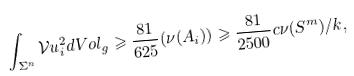<formula> <loc_0><loc_0><loc_500><loc_500>\int _ { \Sigma ^ { n } } \mathcal { V } u _ { i } ^ { 2 } d V o l _ { g } \geqslant \frac { 8 1 } { 6 2 5 } ( \nu ( A _ { i } ) ) \geqslant \frac { 8 1 } { 2 5 0 0 } c \nu ( S ^ { m } ) / k ,</formula> 